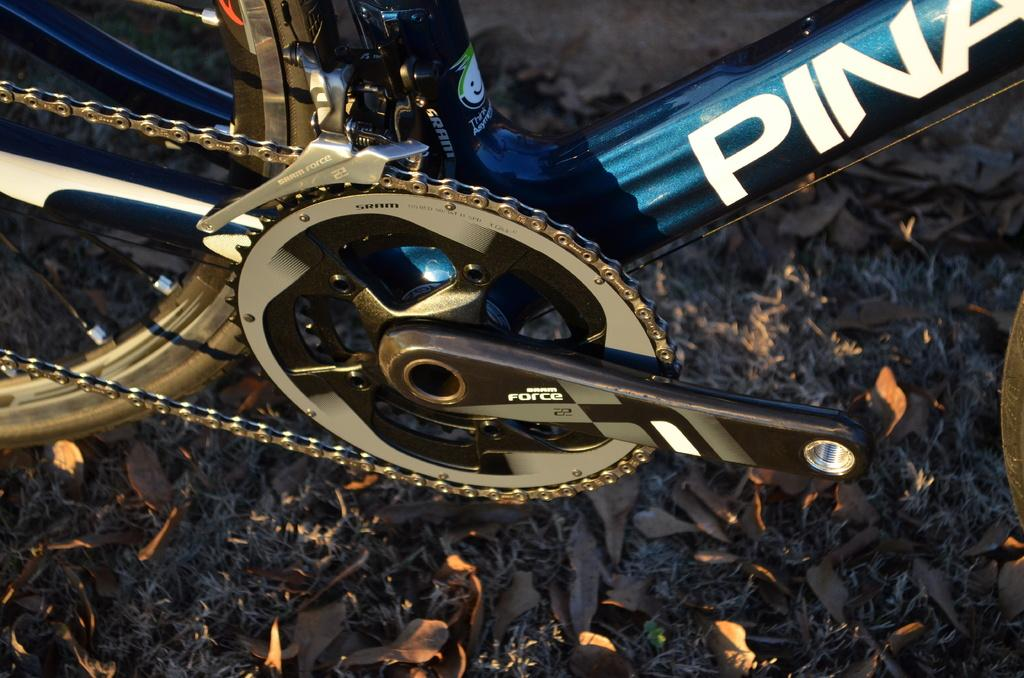What is the main object in the image? There is a bicycle in the image. How much of the bicycle is visible in the image? The bicycle appears to be truncated or partially visible in the image. What else can be seen in the image besides the bicycle? There are dried leaves in the image. What type of hammer can be seen hanging on the wall in the image? There is no hammer present in the image; it only features a bicycle and dried leaves. What type of church is visible in the background of the image? There is no church visible in the image; it only features a bicycle and dried leaves. 